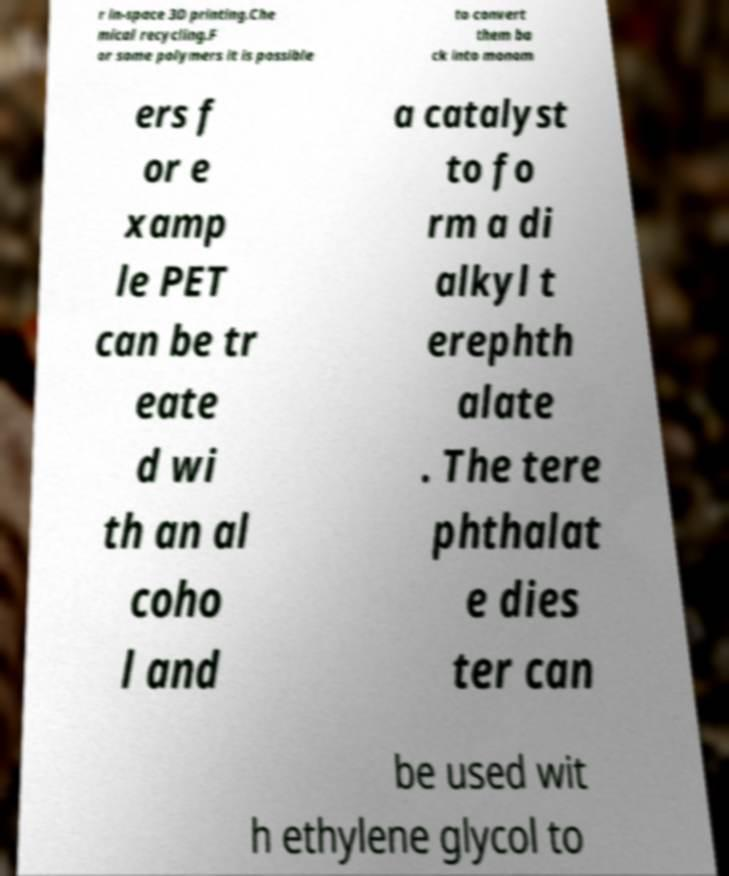I need the written content from this picture converted into text. Can you do that? r in-space 3D printing.Che mical recycling.F or some polymers it is possible to convert them ba ck into monom ers f or e xamp le PET can be tr eate d wi th an al coho l and a catalyst to fo rm a di alkyl t erephth alate . The tere phthalat e dies ter can be used wit h ethylene glycol to 